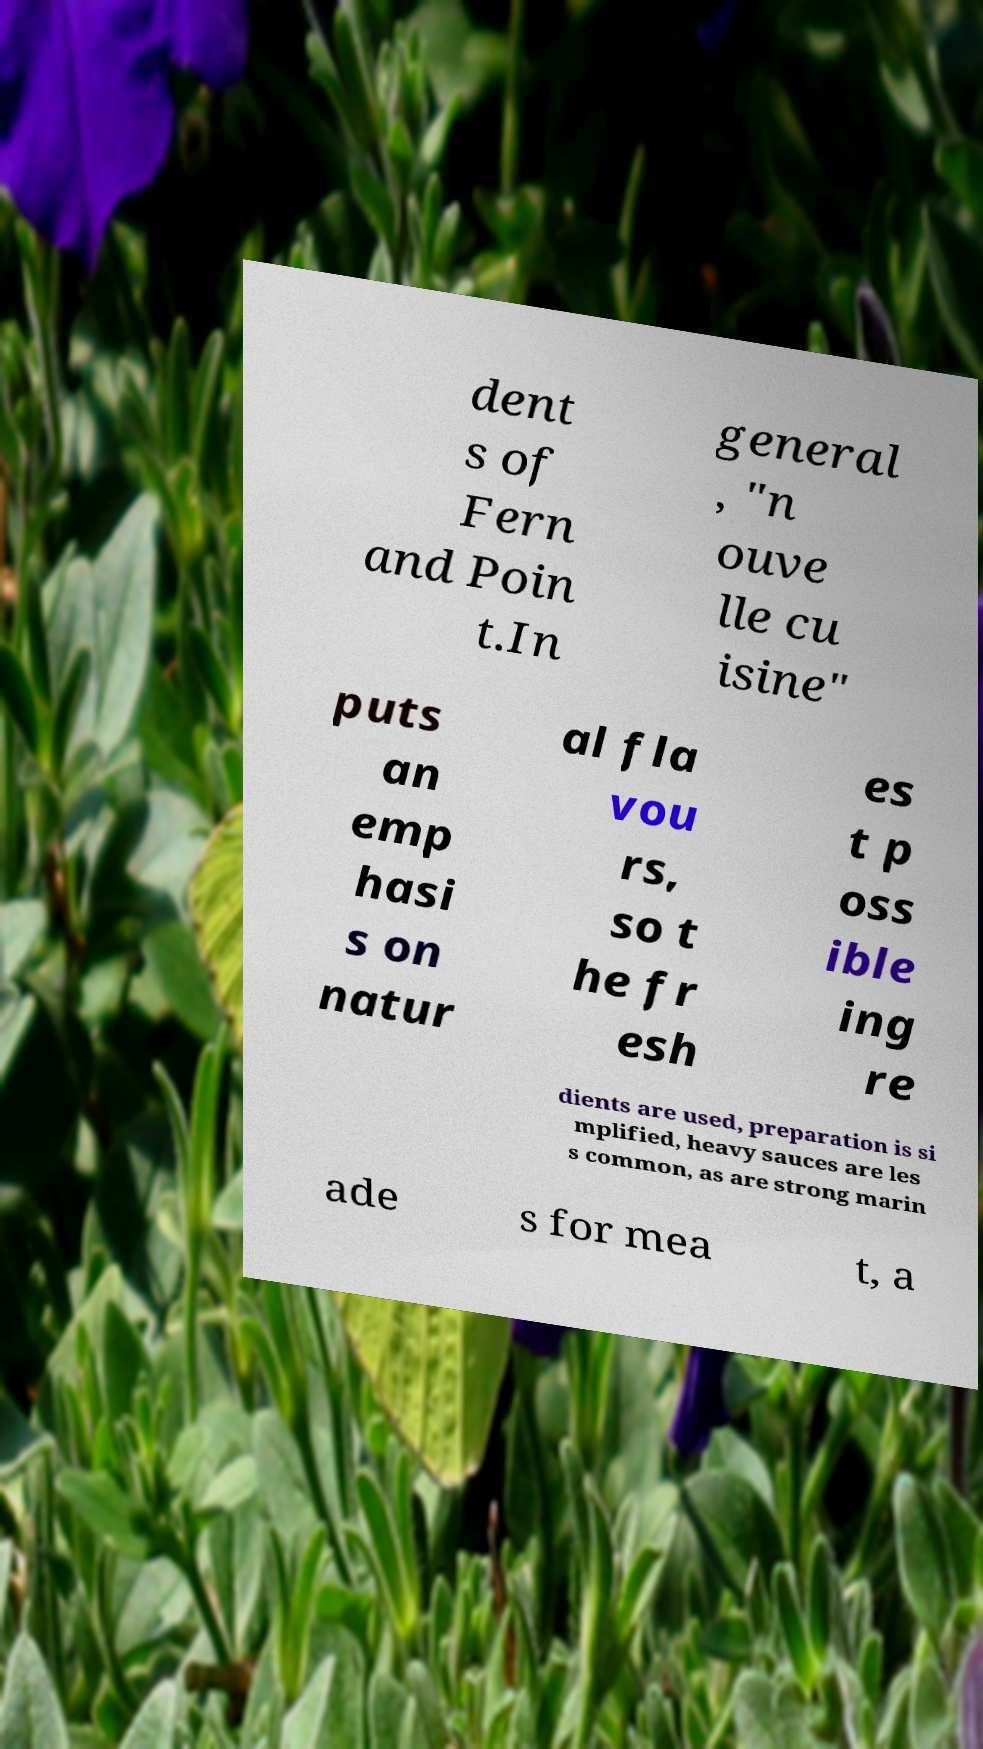Can you accurately transcribe the text from the provided image for me? dent s of Fern and Poin t.In general , "n ouve lle cu isine" puts an emp hasi s on natur al fla vou rs, so t he fr esh es t p oss ible ing re dients are used, preparation is si mplified, heavy sauces are les s common, as are strong marin ade s for mea t, a 